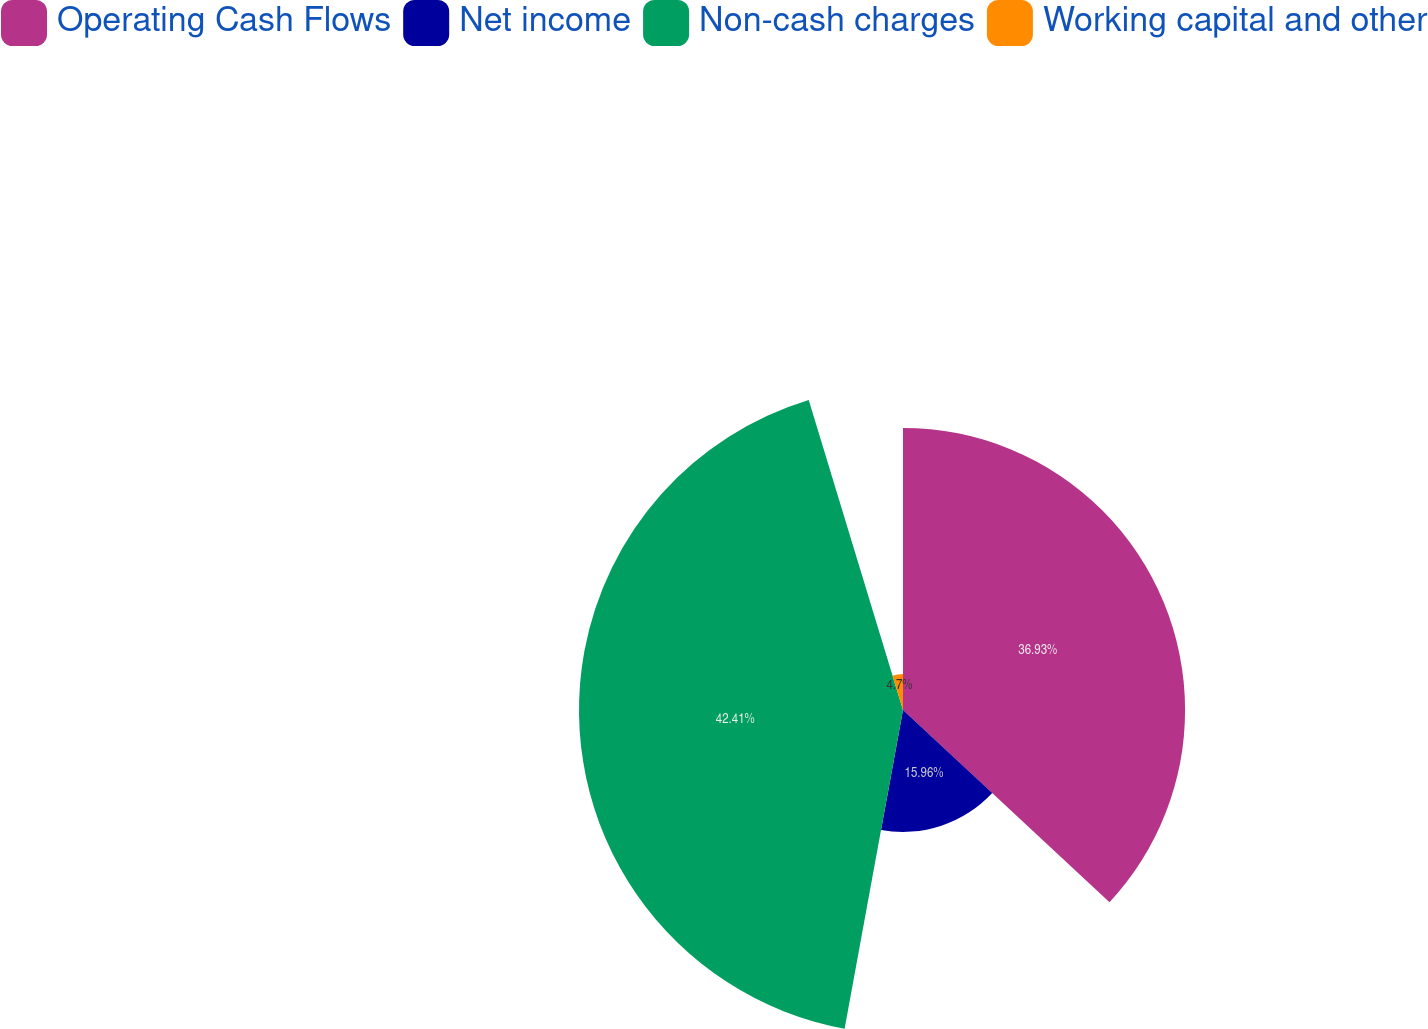Convert chart to OTSL. <chart><loc_0><loc_0><loc_500><loc_500><pie_chart><fcel>Operating Cash Flows<fcel>Net income<fcel>Non-cash charges<fcel>Working capital and other<nl><fcel>36.93%<fcel>15.96%<fcel>42.42%<fcel>4.7%<nl></chart> 